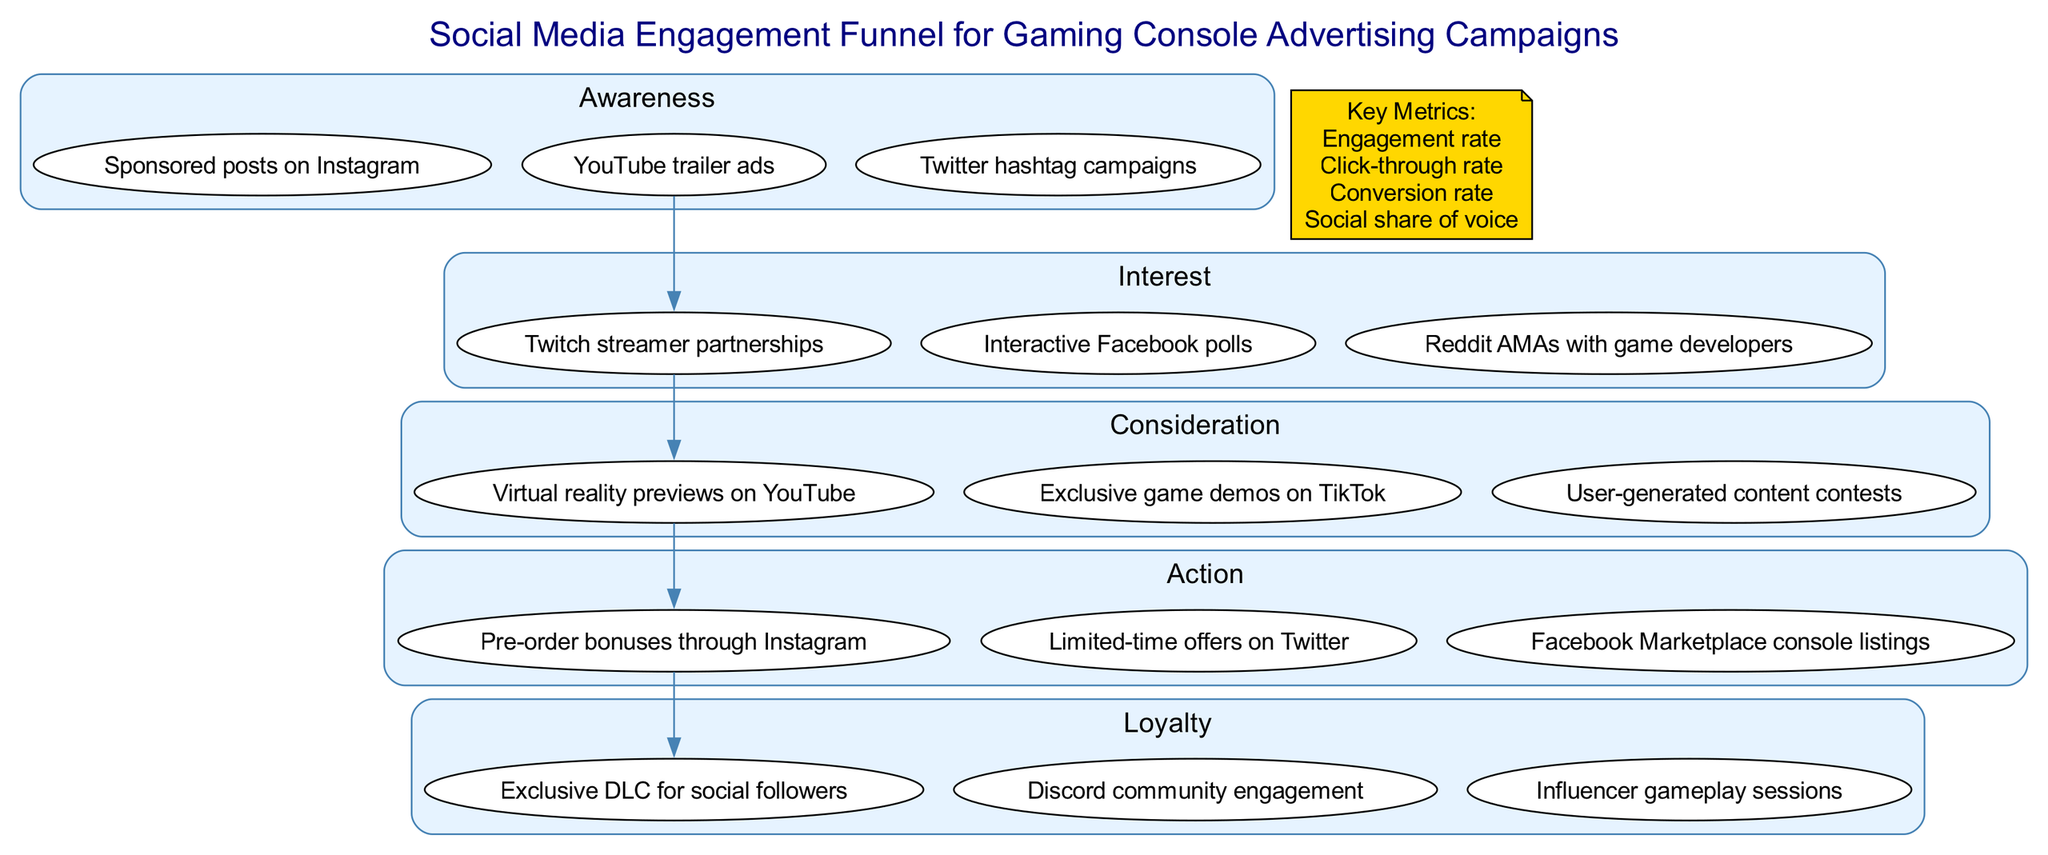What are the activities in the Awareness stage? The Awareness stage includes three activities: Sponsored posts on Instagram, YouTube trailer ads, and Twitter hashtag campaigns. This information can be found directly listed under the Awareness stage in the diagram.
Answer: Sponsored posts on Instagram, YouTube trailer ads, Twitter hashtag campaigns How many stages are represented in the diagram? The diagram represents five stages: Awareness, Interest, Consideration, Action, and Loyalty. This can be confirmed by counting each distinct labeled stage in the funnel.
Answer: 5 What is the final stage of the engagement funnel? The final stage, as shown at the bottom of the funnel, is Loyalty. This is identified by the last listed stage in the series of engagement stages.
Answer: Loyalty Which activity is part of the Consideration stage? One of the activities in the Consideration stage is "Exclusive game demos on TikTok." This activity can be found within the activities listed under the Consideration stage in the diagram.
Answer: Exclusive game demos on TikTok What metric relates to the effectiveness of social shares? The metric related to the effectiveness of social shares is "Social share of voice." This metric is explicitly listed among the key metrics in the diagram.
Answer: Social share of voice How do activities in the Interest stage differ from those in the Action stage? The Interest stage includes activities such as Interactive Facebook polls, Twitch streamer partnerships, and Reddit AMAs with game developers, focused on generating interest. In contrast, the Action stage focuses on driving purchase decisions with activities like Limited-time offers on Twitter. This requires understanding the intent behind the activities in each stage.
Answer: Interactive Facebook polls, Limited-time offers on Twitter What is the first activity in the Awareness stage? The first activity listed in the Awareness stage is "Sponsored posts on Instagram." This can be seen as the top activity under that stage in the diagram.
Answer: Sponsored posts on Instagram Which stage comes directly before the Action stage? The stage that comes directly before the Action stage is Consideration. This can be inferred from the flow of arrows leading from Consideration to Action in the diagram.
Answer: Consideration How many activities are listed in the Loyalty stage? There are three activities listed in the Loyalty stage: Discord community engagement, Exclusive DLC for social followers, and Influencer gameplay sessions. This is confirmed by counting the activities outlined in the Loyalty section of the diagram.
Answer: 3 